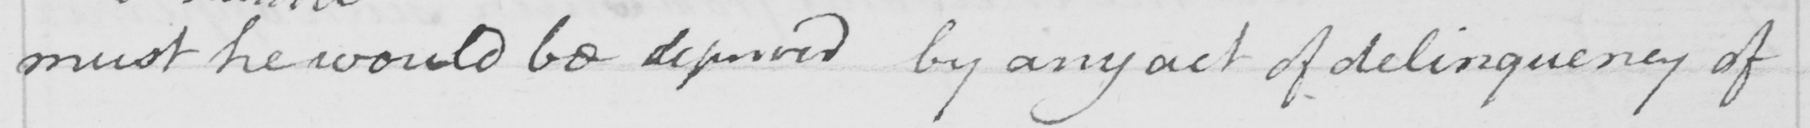Transcribe the text shown in this historical manuscript line. must he would be deprived by any act of delinquency of 